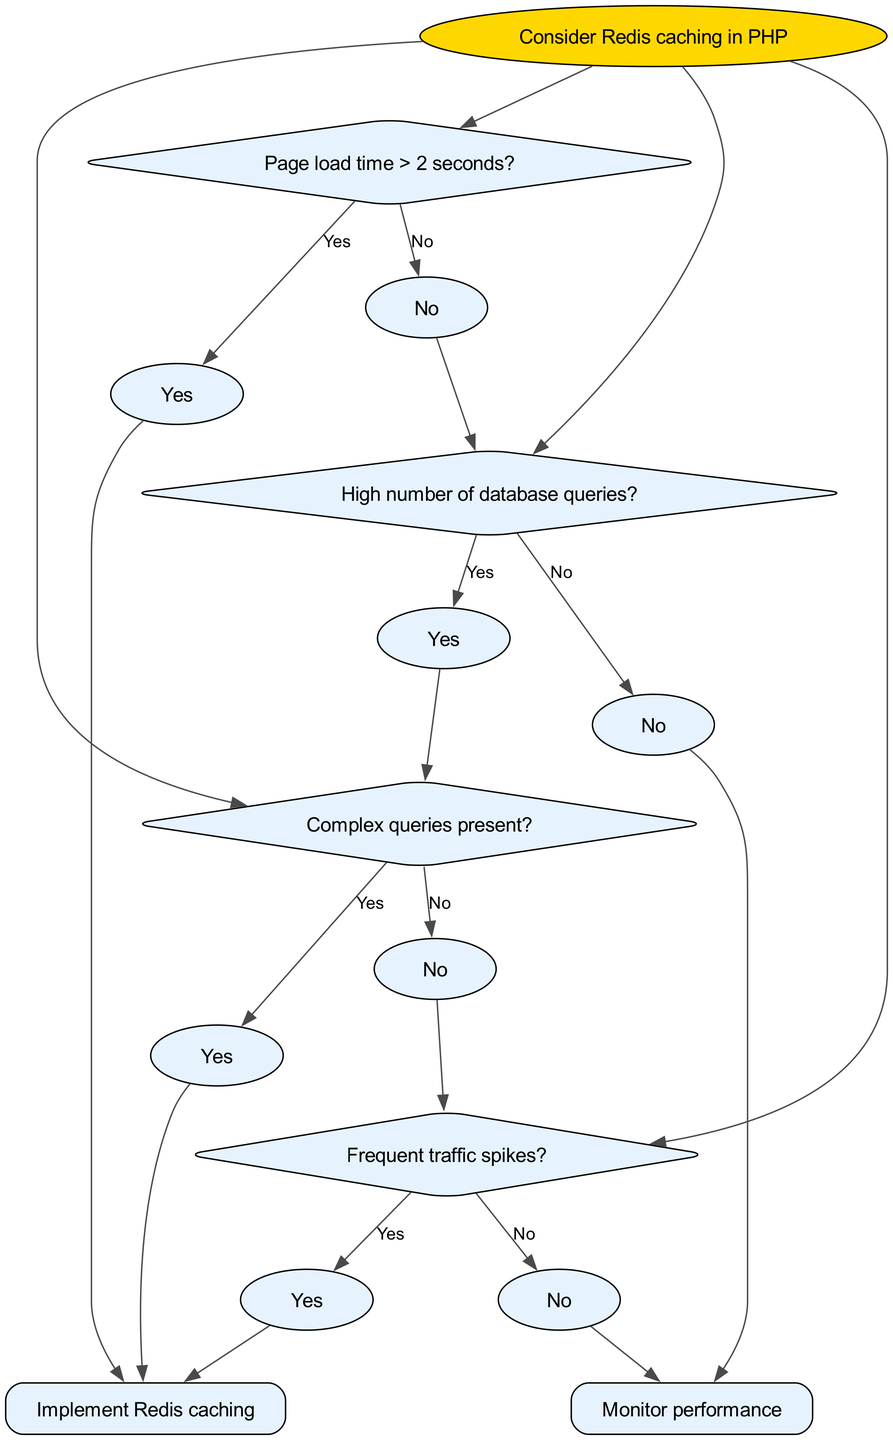What is the root of the decision tree? The root of the decision tree is the initial consideration for implementing Redis caching in PHP, which is the statement: "Consider Redis caching in PHP."
Answer: Consider Redis caching in PHP How many nodes are below the first decision about page load time? The first decision about page load time has two children nodes: one for "Yes" and one for "No."
Answer: 2 If the response time is greater than 2 seconds, what is the next step? If the response time is greater than 2 seconds (Yes response), the next step is to implement Redis caching.
Answer: Implement Redis caching What happens if there is a high number of database queries and no complex queries? If there is a high number of database queries (Yes) and no complex queries (No), the next step is to monitor performance.
Answer: Monitor performance What is the final action if there are frequent traffic spikes? If there are frequent traffic spikes (Yes), the final action is to implement Redis caching.
Answer: Implement Redis caching If the response is "No" to the page load time being greater than 2 seconds and "Yes" to having a high number of database queries, what follows? The flow continues to check if there are complex queries present, which is the next decision after confirming a high number of database queries.
Answer: Complex queries present? What are the two outcomes if the answer to the frequency of traffic spikes is "No"? If the answer to the frequency of traffic spikes is "No," the outcome is to monitor performance as the subsequent step.
Answer: Monitor performance Which nodes lead to implementing Redis caching? The nodes that lead to implementing Redis caching are from the questions: "Page load time > 2 seconds?", "Complex queries present?", and "Frequent traffic spikes?"
Answer: Implement Redis caching What is the relationship between high database queries and complex queries? The relationship is that if there is a high number of database queries, the decision checks if complex queries are present as the next step in the flow.
Answer: Complex queries present? What indicates that Redis caching should be implemented in the decision tree? Redis caching should be implemented if any of the following conditions are met: page load time > 2 seconds, complex queries present, or frequent traffic spikes.
Answer: Conditions met for Redis caching 